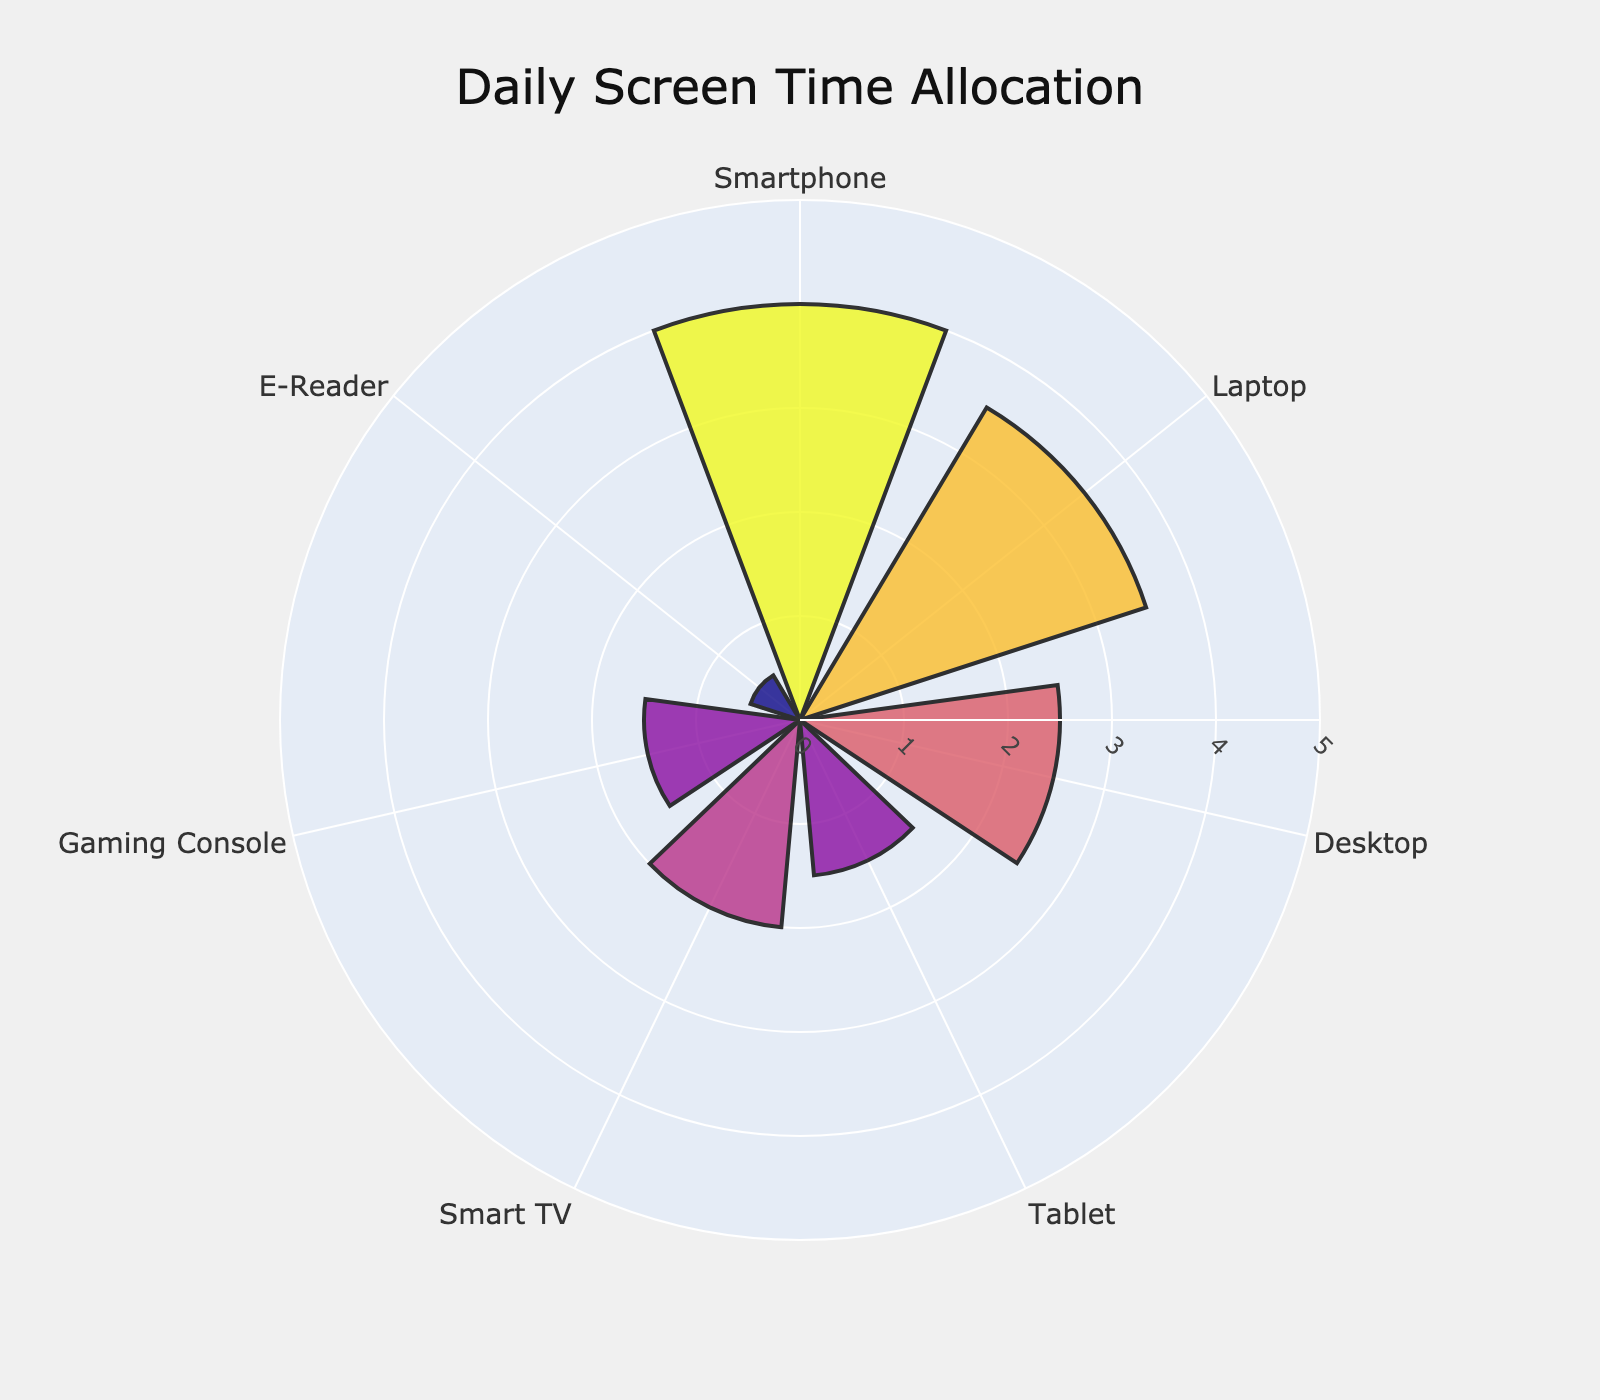Which device has the highest daily screen time? The device with the highest daily screen time can be identified by looking at the segment with the largest radial length in the polar area chart.
Answer: Smartphone Which device has the lowest daily screen time? The device with the lowest daily screen time can be recognized by finding the segment with the shortest radial length in the polar area chart.
Answer: E-Reader What is the combined screen time for Tablet and Smart TV? Add the average daily screen times for Tablet (1.5 hours) and Smart TV (2 hours). 1.5 + 2 = 3.5 hours
Answer: 3.5 hours How much more screen time is spent on Laptops than on Desktops? Subtract the average daily screen time for Desktop (2.5 hours) from that for Laptop (3.5 hours). 3.5 - 2.5 = 1 hour
Answer: 1 hour What is the average daily screen time for all devices? Sum all average daily screen times and divide by the number of devices. (4 + 3.5 + 2.5 + 1.5 + 2 + 1.5 + 0.5) / 7 = 15.5 / 7 ≈ 2.21 hours
Answer: Approximately 2.21 hours Which device category's segment color is the darkest? Darker colors represent higher screen times in the polar area chart. The darkest segment corresponds to the device with the highest average daily screen time.
Answer: Smartphone How does the screen time of Gaming Console compare to that of Tablet? Compare the radial lengths of the segments for Gaming Console (1.5 hours) and Tablet (1.5 hours). Both are equal.
Answer: Same What is the total screen time for all devices combined? Add the average daily screen times for all devices. 4 + 3.5 + 2.5 + 1.5 + 2 + 1.5 + 0.5 = 15.5 hours
Answer: 15.5 hours Which device has a screen time closest to the average daily screen time of all devices? Calculate the average daily screen time (approximately 2.21 hours) and find the device with screen time closest to this value.
Answer: Desktop 